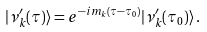Convert formula to latex. <formula><loc_0><loc_0><loc_500><loc_500>| \nu _ { k } ^ { \prime } ( \tau ) \rangle = e ^ { - i m _ { k } ( \tau - \tau _ { 0 } ) } | \nu _ { k } ^ { \prime } ( \tau _ { 0 } ) \rangle \, .</formula> 